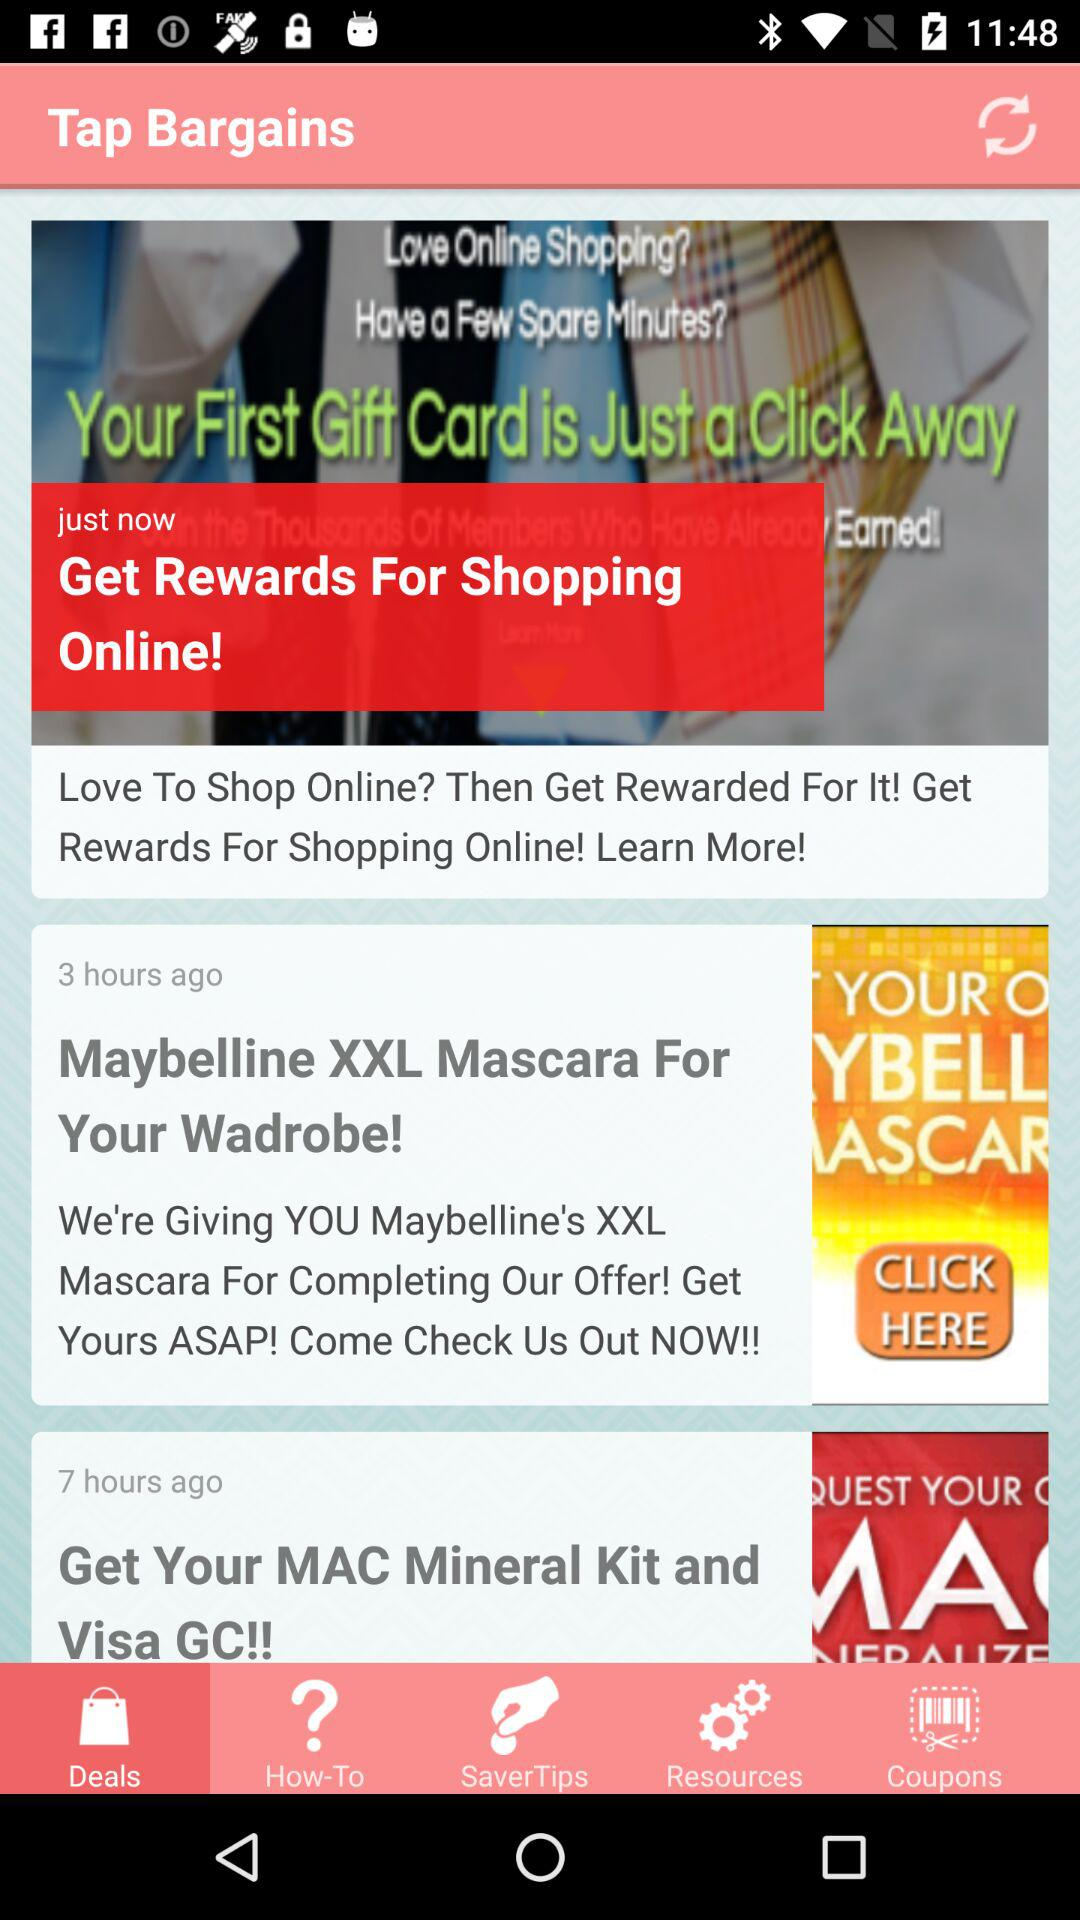What is the application name? The application name is "Tap Bargains". 